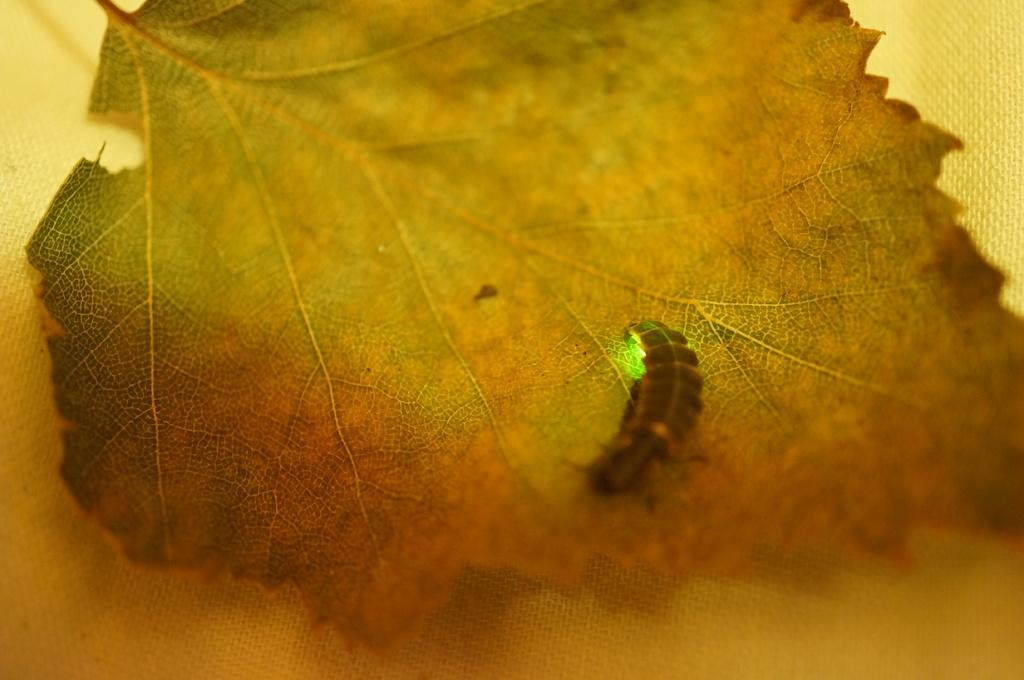What is present in the image along with the leaf? There is an insect in the image. Can you describe the leaf in the image? The leaf has green and brown colors. What color is the background of the image? The background of the image is yellow. How many yaks are visible in the image? There are no yaks present in the image. What point is the insect trying to make in the image? The insect is not making any point in the image; it is simply present on the leaf. 